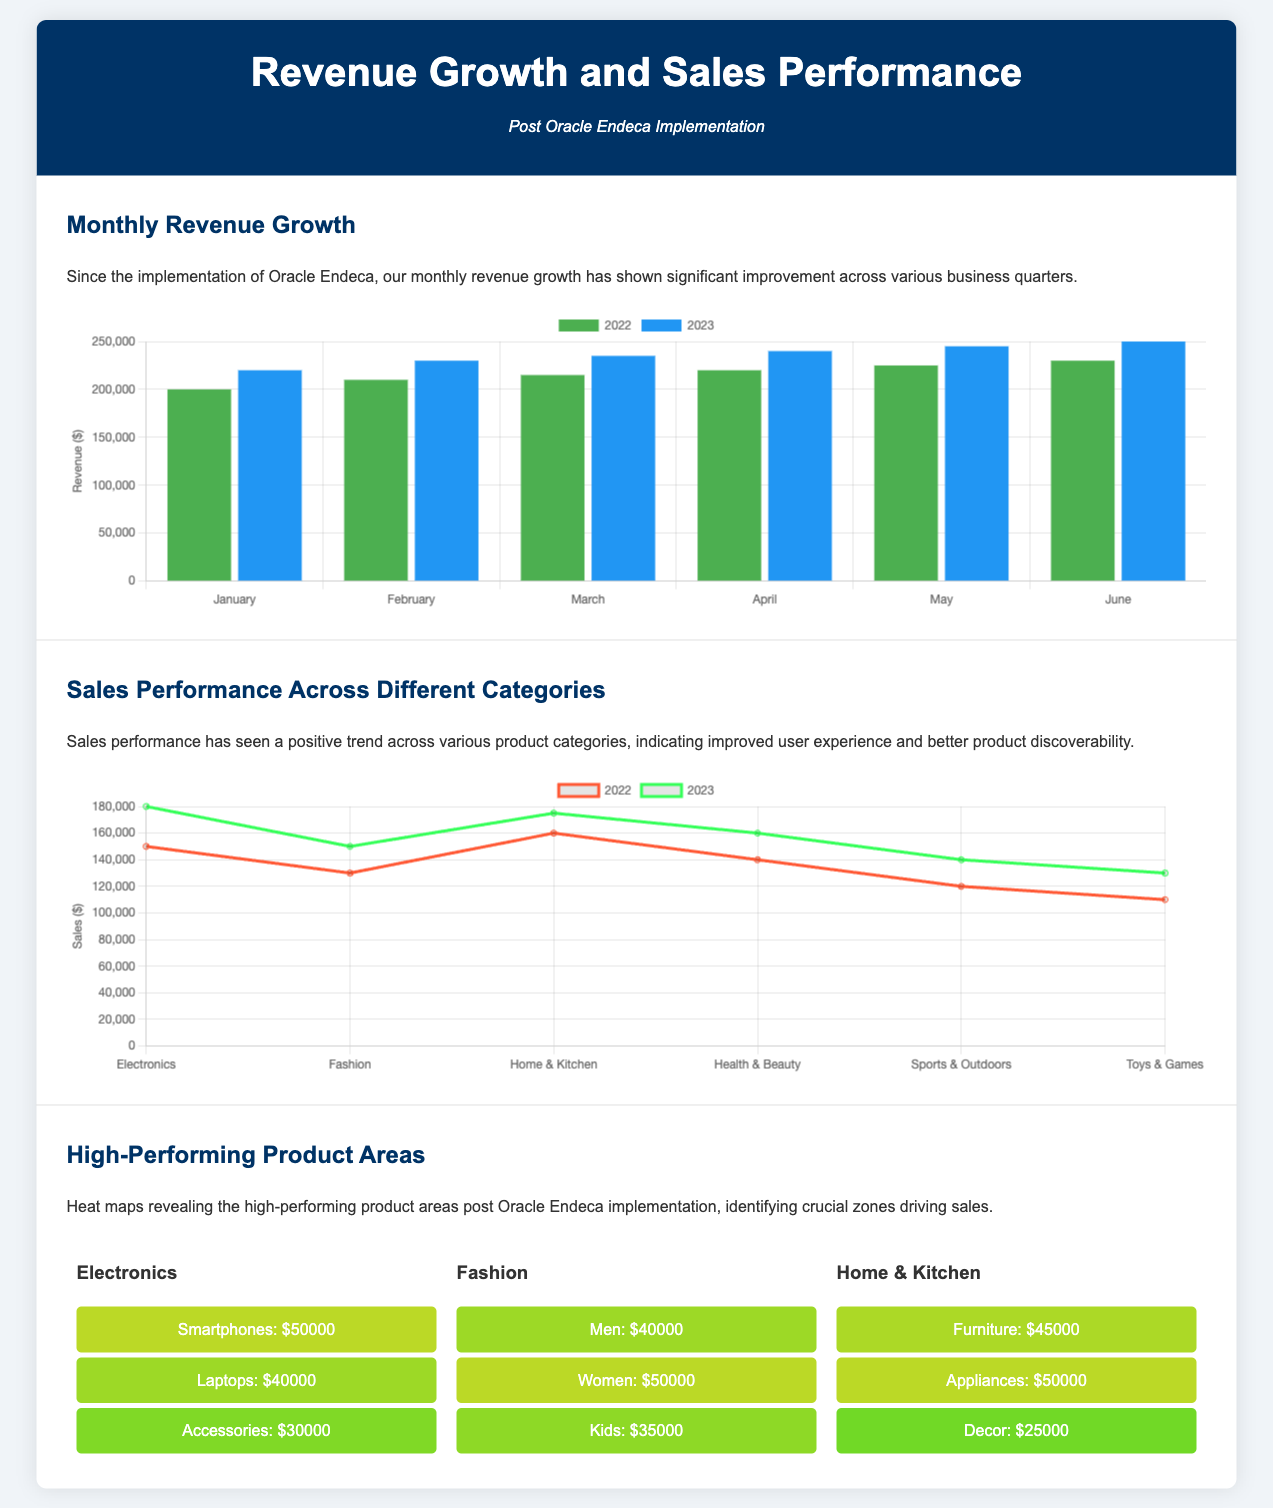what was the revenue in June 2023? The bar chart shows that the revenue in June 2023 is $250,000.
Answer: $250,000 which category had the highest sales in 2023? The line chart indicates that the Electronics category had the highest sales in 2023, at $180,000.
Answer: Electronics how much revenue did the company earn in February 2022? The bar chart illustrates that the revenue in February 2022 was $210,000.
Answer: $210,000 what was the sales figure for Fashion in 2022? In the line chart, the sales figure for Fashion in 2022 is recorded as $130,000.
Answer: $130,000 which product area generated revenue of $50,000 in Fashion? The heat map shows that the Women sub-category generated revenue of $50,000 in Fashion.
Answer: Women what demonstrates the improvement in sales performance in 2023 compared to 2022? The line chart highlights that all product categories showed an increase in sales from 2022 to 2023.
Answer: Improvement which month experienced the lowest revenue growth in 2022? The bar chart indicates that the lowest revenue growth in 2022 occurred in January at $200,000.
Answer: January what is the sales figure for Home & Kitchen in 2023? The line chart shows the sales figure for Home & Kitchen in 2023 is $175,000.
Answer: $175,000 what color represents the revenue data for 2022 in the bar chart? The revenue data for 2022 is represented in green in the bar chart.
Answer: Green 